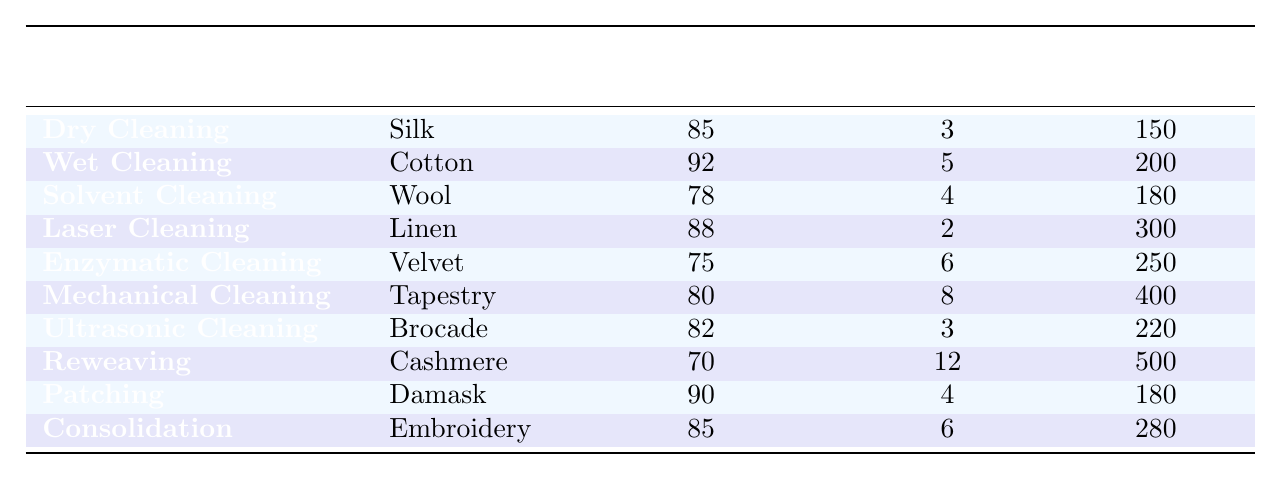What is the success rate of the Wet Cleaning technique on Cotton? The table indicates that the success rate for Wet Cleaning applied to Cotton is directly listed as 92%.
Answer: 92% Which restoration technique has the highest success rate? By comparing the success rates listed in the table, Wet Cleaning has the highest success rate at 92%.
Answer: Wet Cleaning How much does it cost to restore Velvet using Enzymatic Cleaning? The cost listed for restoring Velvet with Enzymatic Cleaning is 250 USD.
Answer: 250 USD What is the average success rate of all restoration techniques listed in the table? The success rates are: 85, 92, 78, 88, 75, 80, 82, 70, 90, 85. Adding them up (85 + 92 + 78 + 88 + 75 + 80 + 82 + 70 + 90 + 85) gives  930. Dividing by 10 (the number of techniques) gives an average of 93.0.
Answer: 93.0 How much more expensive is Reweaving compared to Patching? The cost of Reweaving is 500 USD, while the cost of Patching is 180 USD. The difference is 500 - 180 = 320 USD.
Answer: 320 USD Does Ultrasonic Cleaning have a success rate greater than 80%? The success rate for Ultrasonic Cleaning is 82%, which is indeed greater than 80%.
Answer: Yes Which textile materials require more than 6 hours for restoration? Reviewing the table, Tapestry (8 hours) and Reweaving (12 hours) are the only materials that require more than 6 hours for their restoration techniques.
Answer: Tapestry and Cashmere What is the total cost for reconstructing both Damask using Patching and Cashmere using Reweaving? Patching costs 180 USD and Reweaving costs 500 USD. Adding these together gives a total of 180 + 500 = 680 USD.
Answer: 680 USD Is the success rate for Mechanical Cleaning on Tapestry less than 80%? The success rate for Mechanical Cleaning on Tapestry is noted as 80%, which is not less than 80%.
Answer: No What restoration technique has the lowest success rate and what is that rate? The technique with the lowest success rate is Reweaving, which has a success rate of 70%.
Answer: Reweaving, 70% 